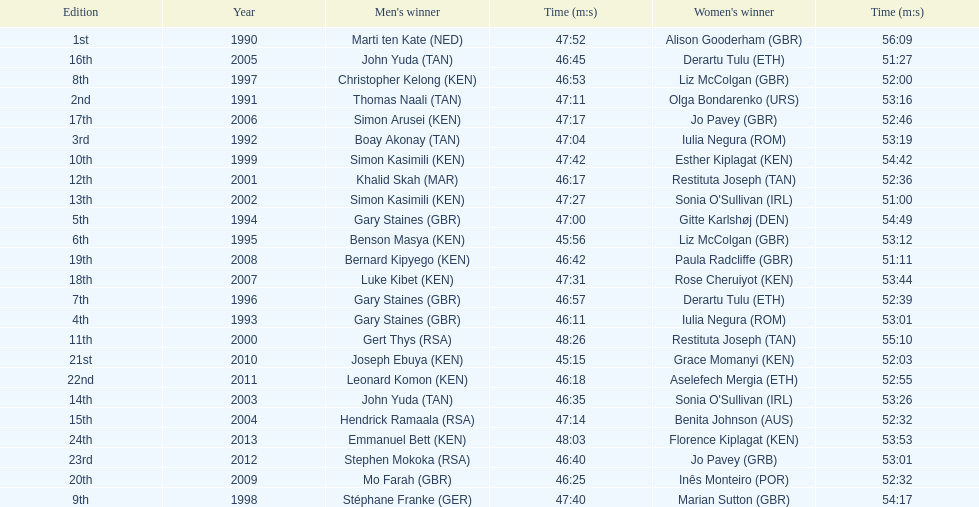Who were all the runners' times between 1990 and 2013? 47:52, 56:09, 47:11, 53:16, 47:04, 53:19, 46:11, 53:01, 47:00, 54:49, 45:56, 53:12, 46:57, 52:39, 46:53, 52:00, 47:40, 54:17, 47:42, 54:42, 48:26, 55:10, 46:17, 52:36, 47:27, 51:00, 46:35, 53:26, 47:14, 52:32, 46:45, 51:27, 47:17, 52:46, 47:31, 53:44, 46:42, 51:11, 46:25, 52:32, 45:15, 52:03, 46:18, 52:55, 46:40, 53:01, 48:03, 53:53. Which was the fastest time? 45:15. Who ran that time? Joseph Ebuya (KEN). 